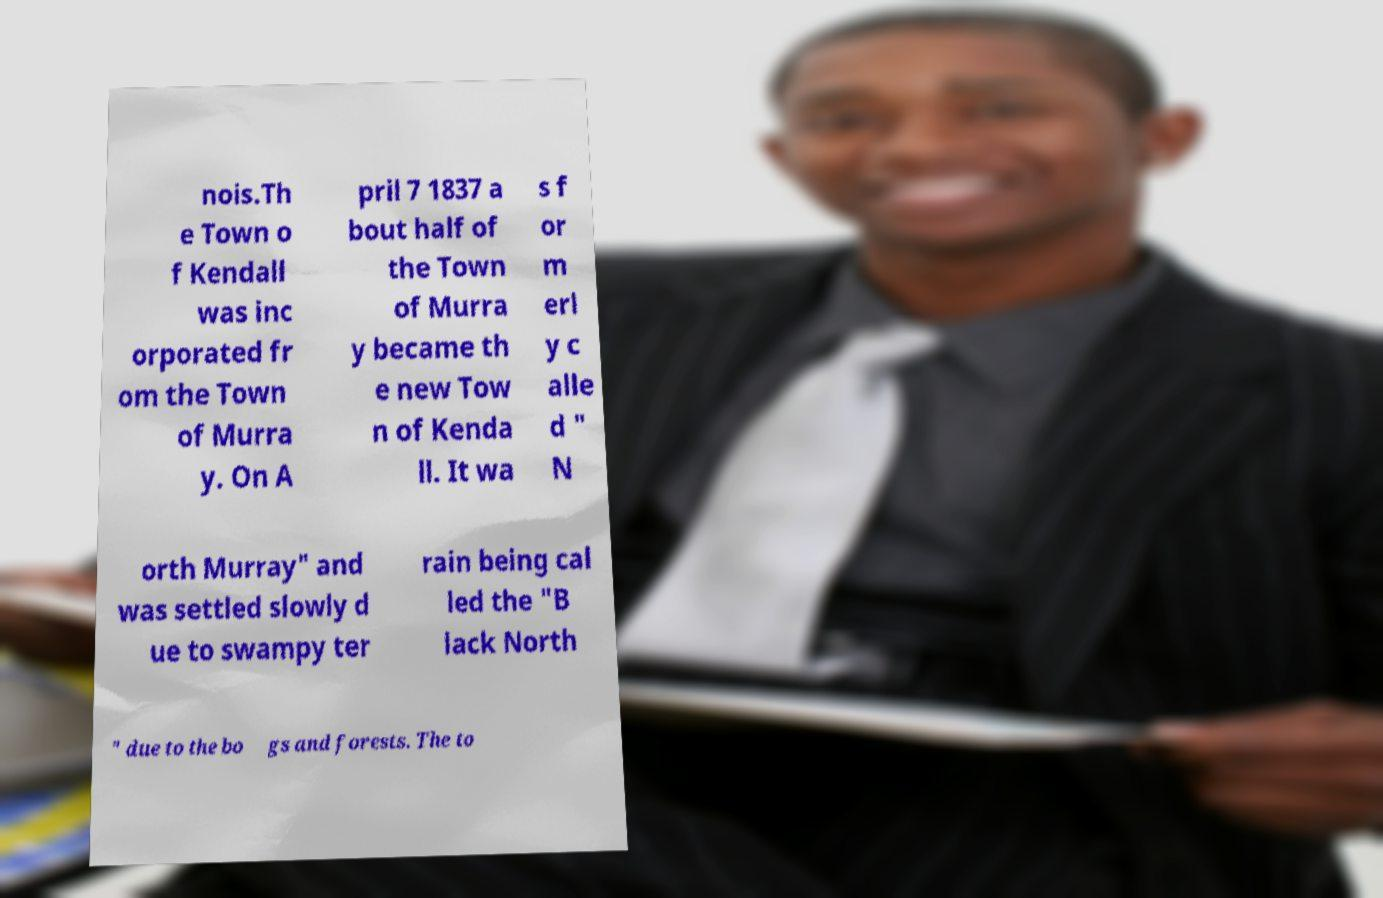Could you extract and type out the text from this image? nois.Th e Town o f Kendall was inc orporated fr om the Town of Murra y. On A pril 7 1837 a bout half of the Town of Murra y became th e new Tow n of Kenda ll. It wa s f or m erl y c alle d " N orth Murray" and was settled slowly d ue to swampy ter rain being cal led the "B lack North " due to the bo gs and forests. The to 